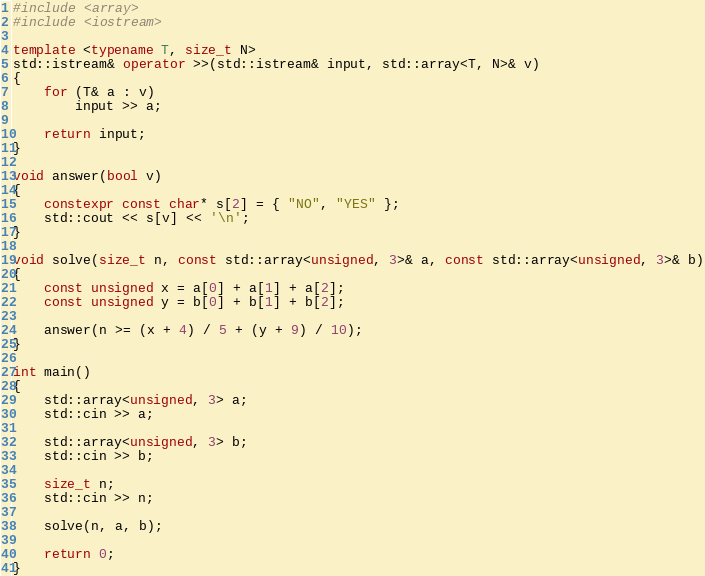<code> <loc_0><loc_0><loc_500><loc_500><_C++_>#include <array>
#include <iostream>

template <typename T, size_t N>
std::istream& operator >>(std::istream& input, std::array<T, N>& v)
{
    for (T& a : v)
        input >> a;

    return input;
}

void answer(bool v)
{
    constexpr const char* s[2] = { "NO", "YES" };
    std::cout << s[v] << '\n';
}

void solve(size_t n, const std::array<unsigned, 3>& a, const std::array<unsigned, 3>& b)
{
    const unsigned x = a[0] + a[1] + a[2];
    const unsigned y = b[0] + b[1] + b[2];

    answer(n >= (x + 4) / 5 + (y + 9) / 10);
}

int main()
{
    std::array<unsigned, 3> a;
    std::cin >> a;

    std::array<unsigned, 3> b;
    std::cin >> b;

    size_t n;
    std::cin >> n;

    solve(n, a, b);

    return 0;
}

</code> 